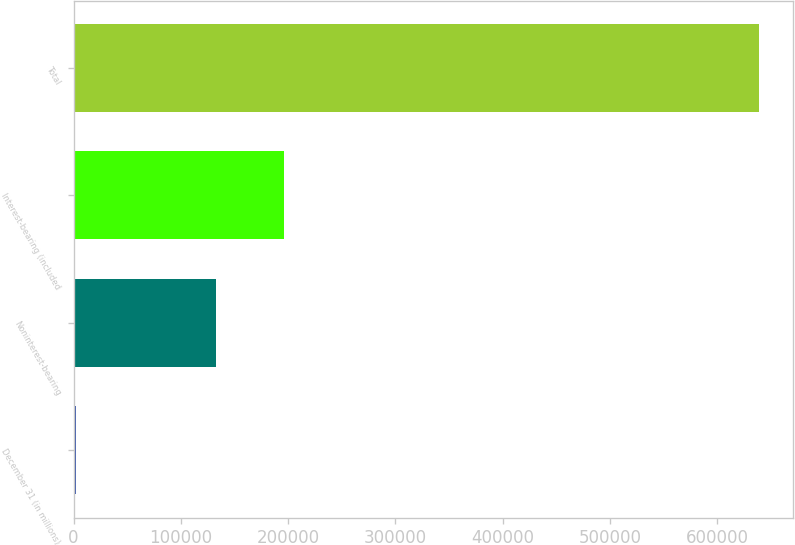Convert chart. <chart><loc_0><loc_0><loc_500><loc_500><bar_chart><fcel>December 31 (in millions)<fcel>Noninterest-bearing<fcel>Interest-bearing (included<fcel>Total<nl><fcel>2006<fcel>132781<fcel>196459<fcel>638788<nl></chart> 